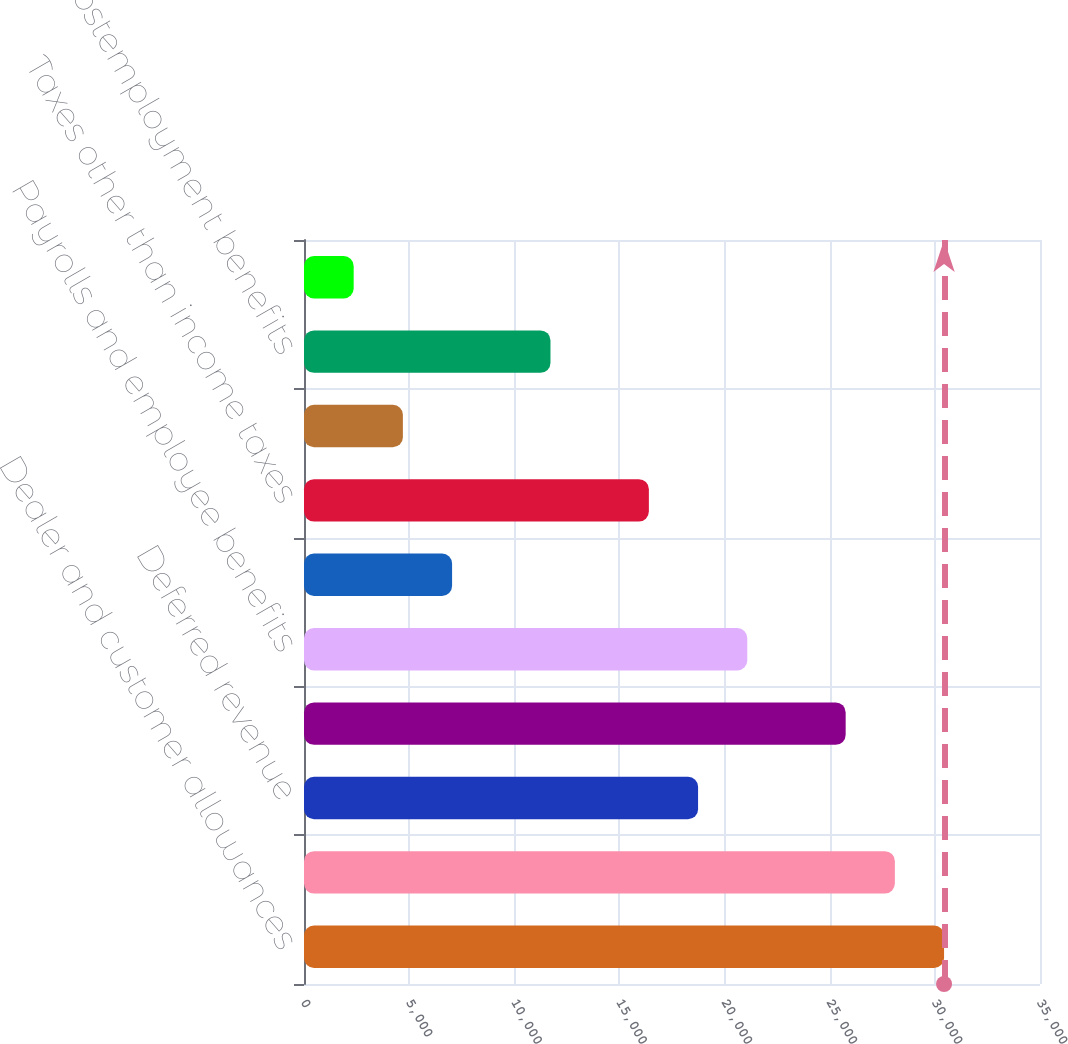Convert chart to OTSL. <chart><loc_0><loc_0><loc_500><loc_500><bar_chart><fcel>Dealer and customer allowances<fcel>Deposits from rental car<fcel>Deferred revenue<fcel>Policy product warranty and<fcel>Payrolls and employee benefits<fcel>Insurance reserves<fcel>Taxes other than income taxes<fcel>Derivative liability<fcel>Postemployment benefits<fcel>Interest<nl><fcel>30437.8<fcel>28098.2<fcel>18739.8<fcel>25758.6<fcel>21079.4<fcel>7041.8<fcel>16400.2<fcel>4702.2<fcel>11721<fcel>2362.6<nl></chart> 